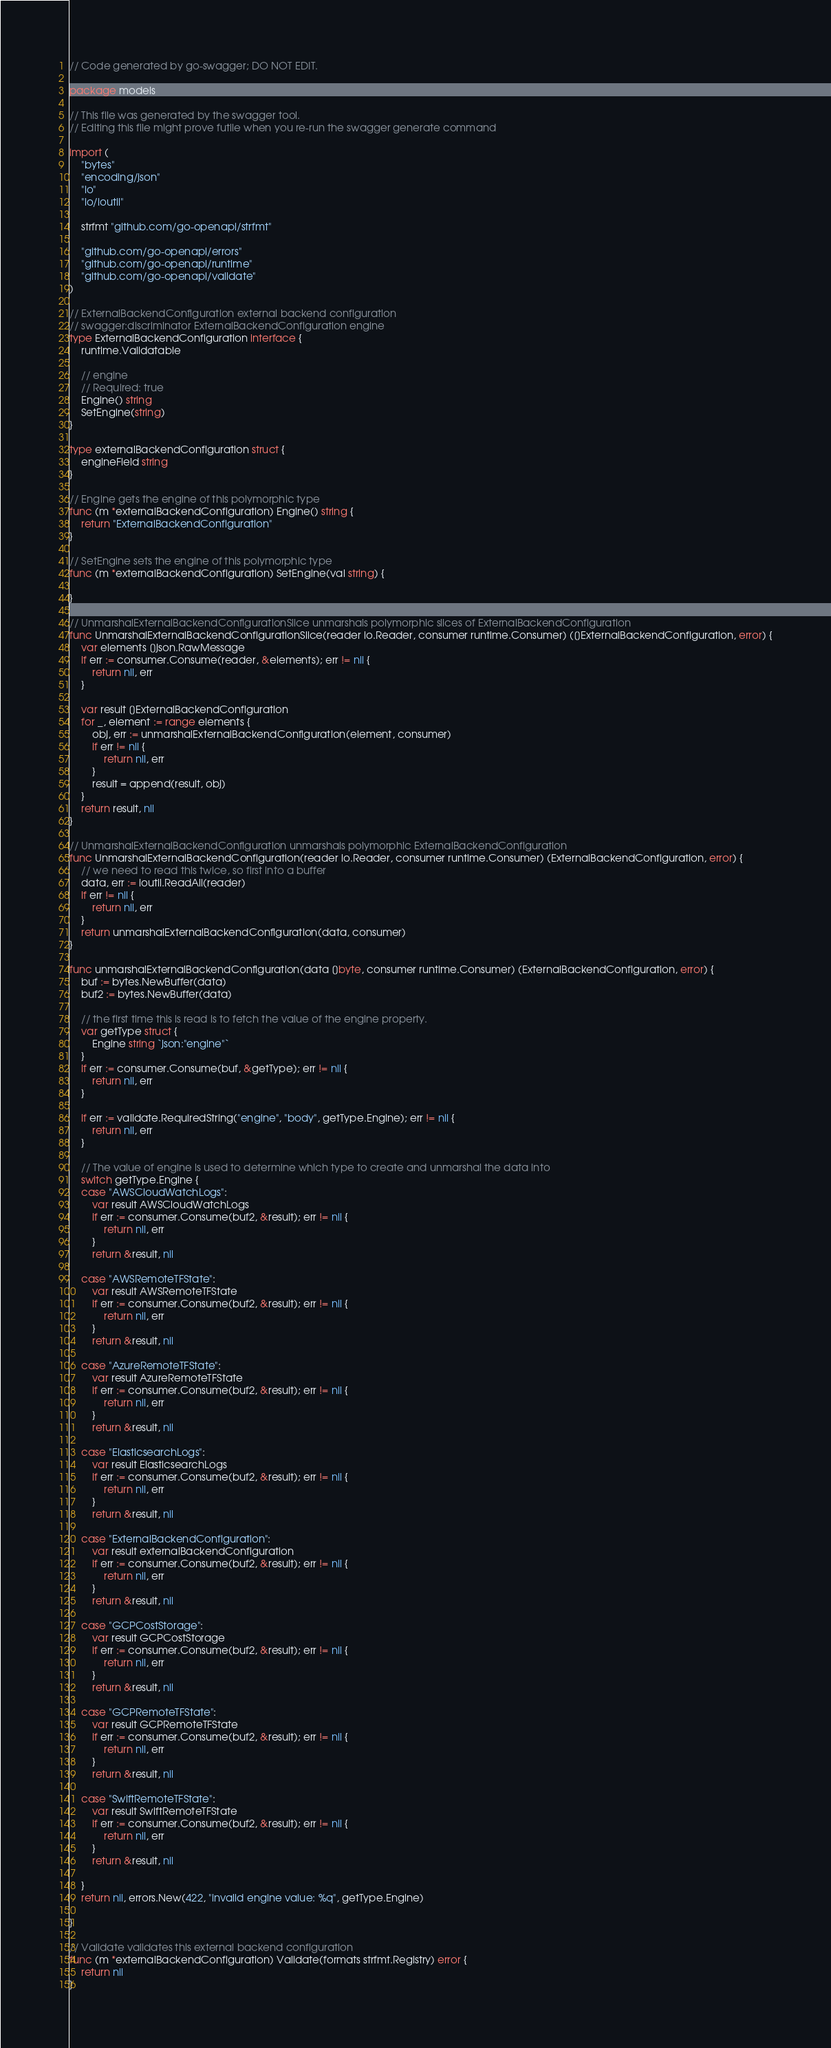<code> <loc_0><loc_0><loc_500><loc_500><_Go_>// Code generated by go-swagger; DO NOT EDIT.

package models

// This file was generated by the swagger tool.
// Editing this file might prove futile when you re-run the swagger generate command

import (
	"bytes"
	"encoding/json"
	"io"
	"io/ioutil"

	strfmt "github.com/go-openapi/strfmt"

	"github.com/go-openapi/errors"
	"github.com/go-openapi/runtime"
	"github.com/go-openapi/validate"
)

// ExternalBackendConfiguration external backend configuration
// swagger:discriminator ExternalBackendConfiguration engine
type ExternalBackendConfiguration interface {
	runtime.Validatable

	// engine
	// Required: true
	Engine() string
	SetEngine(string)
}

type externalBackendConfiguration struct {
	engineField string
}

// Engine gets the engine of this polymorphic type
func (m *externalBackendConfiguration) Engine() string {
	return "ExternalBackendConfiguration"
}

// SetEngine sets the engine of this polymorphic type
func (m *externalBackendConfiguration) SetEngine(val string) {

}

// UnmarshalExternalBackendConfigurationSlice unmarshals polymorphic slices of ExternalBackendConfiguration
func UnmarshalExternalBackendConfigurationSlice(reader io.Reader, consumer runtime.Consumer) ([]ExternalBackendConfiguration, error) {
	var elements []json.RawMessage
	if err := consumer.Consume(reader, &elements); err != nil {
		return nil, err
	}

	var result []ExternalBackendConfiguration
	for _, element := range elements {
		obj, err := unmarshalExternalBackendConfiguration(element, consumer)
		if err != nil {
			return nil, err
		}
		result = append(result, obj)
	}
	return result, nil
}

// UnmarshalExternalBackendConfiguration unmarshals polymorphic ExternalBackendConfiguration
func UnmarshalExternalBackendConfiguration(reader io.Reader, consumer runtime.Consumer) (ExternalBackendConfiguration, error) {
	// we need to read this twice, so first into a buffer
	data, err := ioutil.ReadAll(reader)
	if err != nil {
		return nil, err
	}
	return unmarshalExternalBackendConfiguration(data, consumer)
}

func unmarshalExternalBackendConfiguration(data []byte, consumer runtime.Consumer) (ExternalBackendConfiguration, error) {
	buf := bytes.NewBuffer(data)
	buf2 := bytes.NewBuffer(data)

	// the first time this is read is to fetch the value of the engine property.
	var getType struct {
		Engine string `json:"engine"`
	}
	if err := consumer.Consume(buf, &getType); err != nil {
		return nil, err
	}

	if err := validate.RequiredString("engine", "body", getType.Engine); err != nil {
		return nil, err
	}

	// The value of engine is used to determine which type to create and unmarshal the data into
	switch getType.Engine {
	case "AWSCloudWatchLogs":
		var result AWSCloudWatchLogs
		if err := consumer.Consume(buf2, &result); err != nil {
			return nil, err
		}
		return &result, nil

	case "AWSRemoteTFState":
		var result AWSRemoteTFState
		if err := consumer.Consume(buf2, &result); err != nil {
			return nil, err
		}
		return &result, nil

	case "AzureRemoteTFState":
		var result AzureRemoteTFState
		if err := consumer.Consume(buf2, &result); err != nil {
			return nil, err
		}
		return &result, nil

	case "ElasticsearchLogs":
		var result ElasticsearchLogs
		if err := consumer.Consume(buf2, &result); err != nil {
			return nil, err
		}
		return &result, nil

	case "ExternalBackendConfiguration":
		var result externalBackendConfiguration
		if err := consumer.Consume(buf2, &result); err != nil {
			return nil, err
		}
		return &result, nil

	case "GCPCostStorage":
		var result GCPCostStorage
		if err := consumer.Consume(buf2, &result); err != nil {
			return nil, err
		}
		return &result, nil

	case "GCPRemoteTFState":
		var result GCPRemoteTFState
		if err := consumer.Consume(buf2, &result); err != nil {
			return nil, err
		}
		return &result, nil

	case "SwiftRemoteTFState":
		var result SwiftRemoteTFState
		if err := consumer.Consume(buf2, &result); err != nil {
			return nil, err
		}
		return &result, nil

	}
	return nil, errors.New(422, "invalid engine value: %q", getType.Engine)

}

// Validate validates this external backend configuration
func (m *externalBackendConfiguration) Validate(formats strfmt.Registry) error {
	return nil
}
</code> 